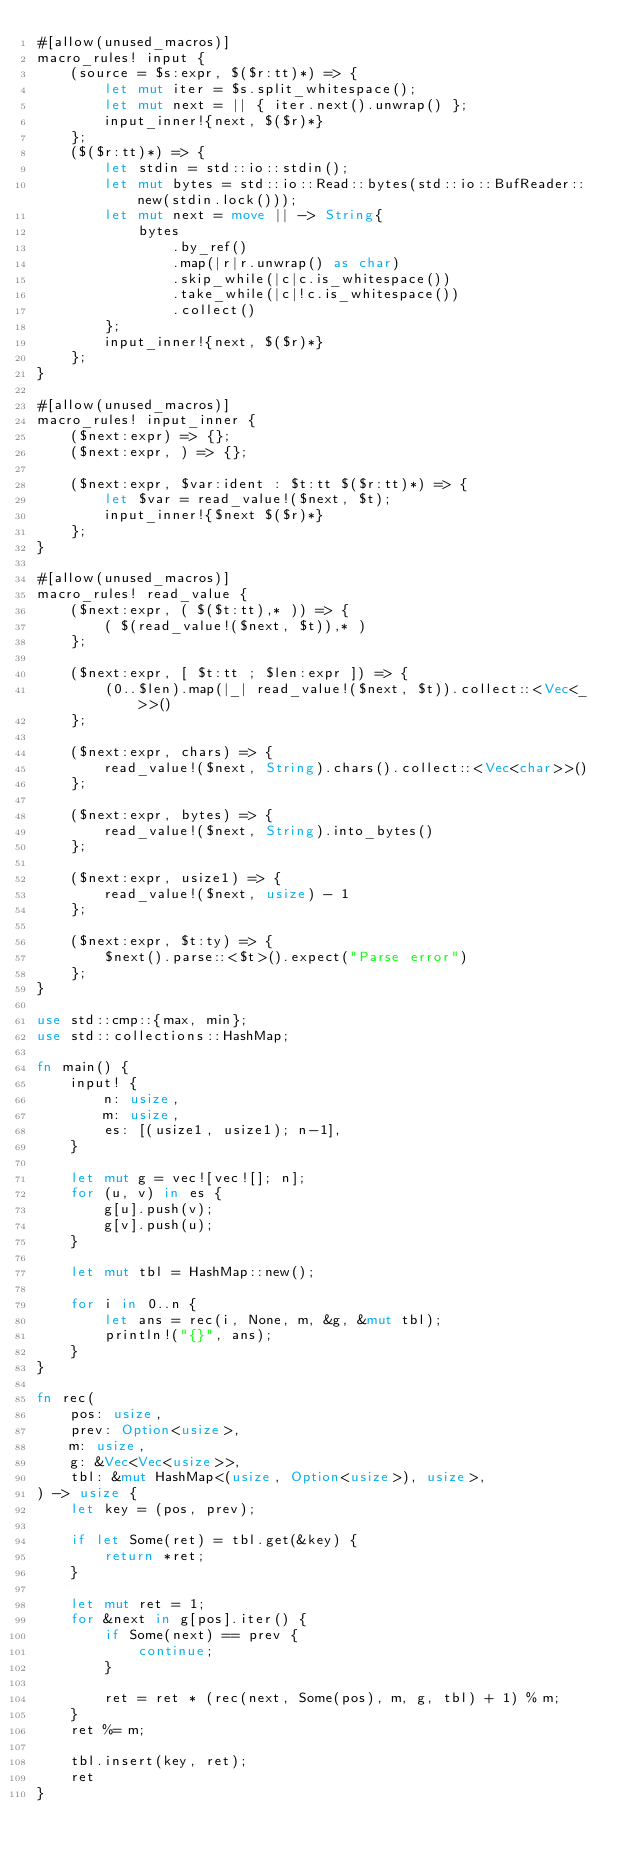<code> <loc_0><loc_0><loc_500><loc_500><_Rust_>#[allow(unused_macros)]
macro_rules! input {
    (source = $s:expr, $($r:tt)*) => {
        let mut iter = $s.split_whitespace();
        let mut next = || { iter.next().unwrap() };
        input_inner!{next, $($r)*}
    };
    ($($r:tt)*) => {
        let stdin = std::io::stdin();
        let mut bytes = std::io::Read::bytes(std::io::BufReader::new(stdin.lock()));
        let mut next = move || -> String{
            bytes
                .by_ref()
                .map(|r|r.unwrap() as char)
                .skip_while(|c|c.is_whitespace())
                .take_while(|c|!c.is_whitespace())
                .collect()
        };
        input_inner!{next, $($r)*}
    };
}

#[allow(unused_macros)]
macro_rules! input_inner {
    ($next:expr) => {};
    ($next:expr, ) => {};

    ($next:expr, $var:ident : $t:tt $($r:tt)*) => {
        let $var = read_value!($next, $t);
        input_inner!{$next $($r)*}
    };
}

#[allow(unused_macros)]
macro_rules! read_value {
    ($next:expr, ( $($t:tt),* )) => {
        ( $(read_value!($next, $t)),* )
    };

    ($next:expr, [ $t:tt ; $len:expr ]) => {
        (0..$len).map(|_| read_value!($next, $t)).collect::<Vec<_>>()
    };

    ($next:expr, chars) => {
        read_value!($next, String).chars().collect::<Vec<char>>()
    };

    ($next:expr, bytes) => {
        read_value!($next, String).into_bytes()
    };

    ($next:expr, usize1) => {
        read_value!($next, usize) - 1
    };

    ($next:expr, $t:ty) => {
        $next().parse::<$t>().expect("Parse error")
    };
}

use std::cmp::{max, min};
use std::collections::HashMap;

fn main() {
    input! {
        n: usize,
        m: usize,
        es: [(usize1, usize1); n-1],
    }

    let mut g = vec![vec![]; n];
    for (u, v) in es {
        g[u].push(v);
        g[v].push(u);
    }

    let mut tbl = HashMap::new();

    for i in 0..n {
        let ans = rec(i, None, m, &g, &mut tbl);
        println!("{}", ans);
    }
}

fn rec(
    pos: usize,
    prev: Option<usize>,
    m: usize,
    g: &Vec<Vec<usize>>,
    tbl: &mut HashMap<(usize, Option<usize>), usize>,
) -> usize {
    let key = (pos, prev);

    if let Some(ret) = tbl.get(&key) {
        return *ret;
    }

    let mut ret = 1;
    for &next in g[pos].iter() {
        if Some(next) == prev {
            continue;
        }

        ret = ret * (rec(next, Some(pos), m, g, tbl) + 1) % m;
    }
    ret %= m;

    tbl.insert(key, ret);
    ret
}
</code> 